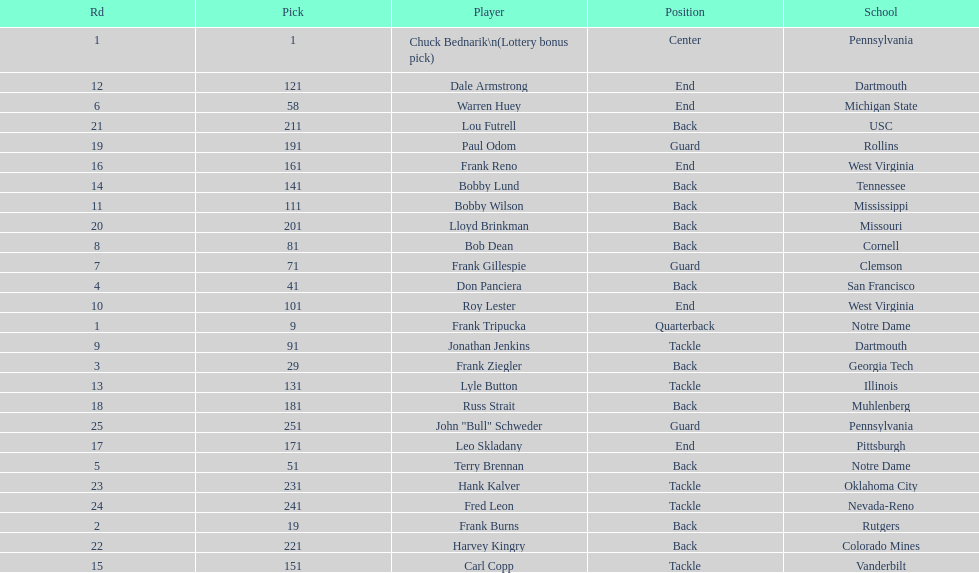Most prevalent school Pennsylvania. 